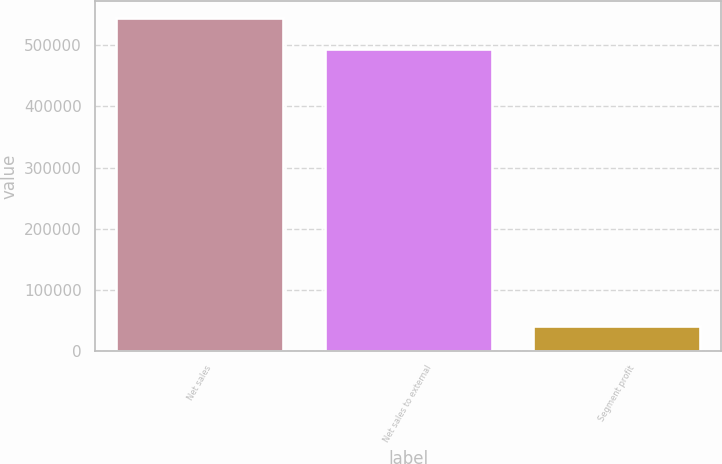Convert chart. <chart><loc_0><loc_0><loc_500><loc_500><bar_chart><fcel>Net sales<fcel>Net sales to external<fcel>Segment profit<nl><fcel>545439<fcel>494921<fcel>40185<nl></chart> 